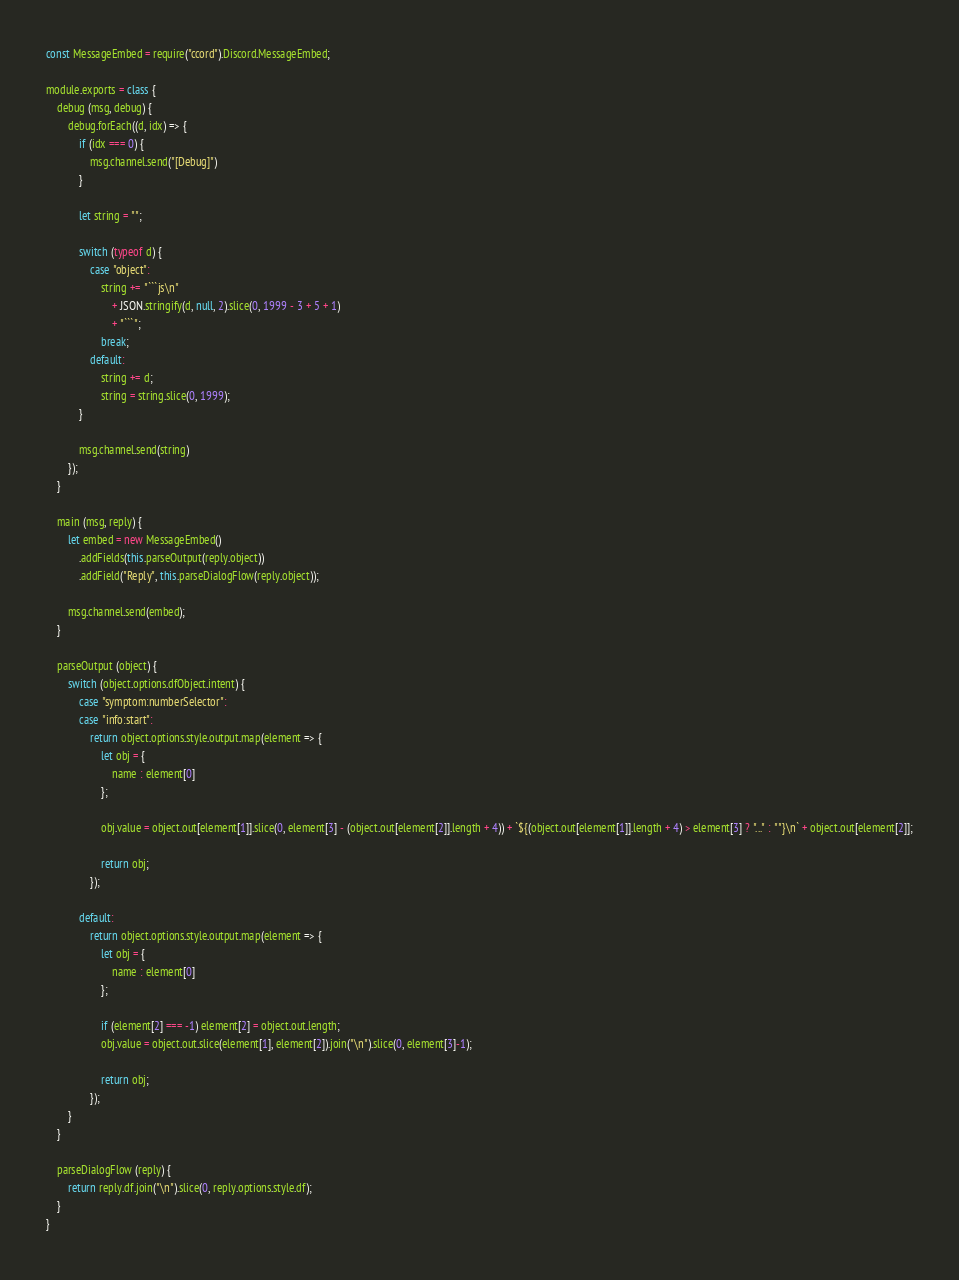<code> <loc_0><loc_0><loc_500><loc_500><_JavaScript_>const MessageEmbed = require("ccord").Discord.MessageEmbed;

module.exports = class {
    debug (msg, debug) {
        debug.forEach((d, idx) => {
            if (idx === 0) {
                msg.channel.send("[Debug]")
            }

            let string = "";

            switch (typeof d) {
                case "object":
                    string += "```js\n"
                        + JSON.stringify(d, null, 2).slice(0, 1999 - 3 + 5 + 1)
                        + "```";
                    break;
                default:
                    string += d;
                    string = string.slice(0, 1999);
            }

            msg.channel.send(string)
        });
    }

    main (msg, reply) {
        let embed = new MessageEmbed()
            .addFields(this.parseOutput(reply.object))
            .addField("Reply", this.parseDialogFlow(reply.object));

        msg.channel.send(embed);
    }

    parseOutput (object) {
        switch (object.options.dfObject.intent) {
            case "symptom:numberSelector":
            case "info:start":
                return object.options.style.output.map(element => {
                    let obj = {
                        name : element[0]
                    };

                    obj.value = object.out[element[1]].slice(0, element[3] - (object.out[element[2]].length + 4)) + `${(object.out[element[1]].length + 4) > element[3] ? "..." : ""}\n` + object.out[element[2]];

                    return obj;
                });

            default:
                return object.options.style.output.map(element => {
                    let obj = {
                        name : element[0]
                    };

                    if (element[2] === -1) element[2] = object.out.length;
                    obj.value = object.out.slice(element[1], element[2]).join("\n").slice(0, element[3]-1);

                    return obj;
                });
        }
    }

    parseDialogFlow (reply) {
        return reply.df.join("\n").slice(0, reply.options.style.df);
    }
}</code> 